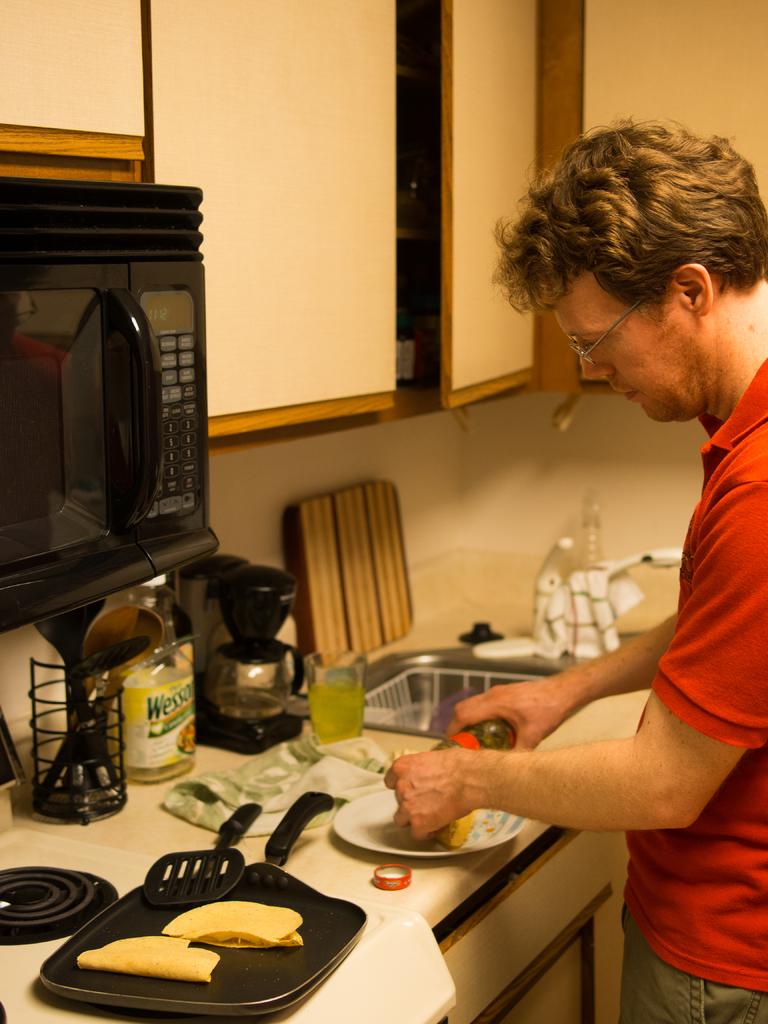What brand of cooking oil is on the counter?
Make the answer very short. Wesson. What color is the oil brand name?
Your answer should be compact. Green. 